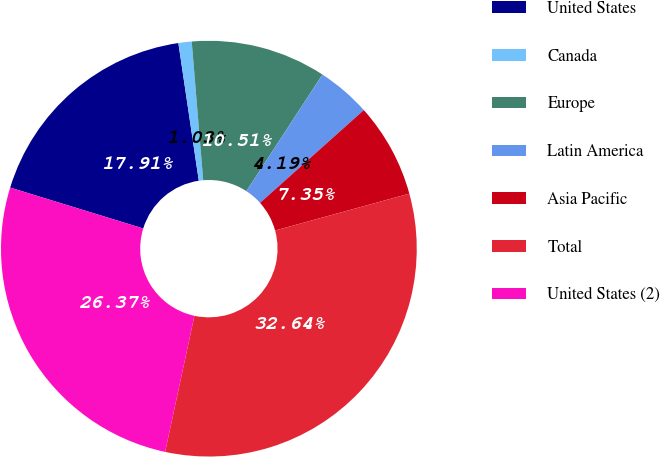Convert chart. <chart><loc_0><loc_0><loc_500><loc_500><pie_chart><fcel>United States<fcel>Canada<fcel>Europe<fcel>Latin America<fcel>Asia Pacific<fcel>Total<fcel>United States (2)<nl><fcel>17.91%<fcel>1.03%<fcel>10.51%<fcel>4.19%<fcel>7.35%<fcel>32.64%<fcel>26.37%<nl></chart> 